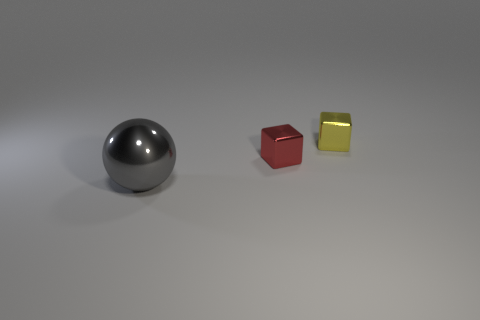There is a shiny cube in front of the small yellow thing; how big is it?
Your answer should be compact. Small. Does the red shiny block have the same size as the gray object in front of the yellow metallic cube?
Keep it short and to the point. No. How many gray shiny balls have the same size as the yellow metallic cube?
Give a very brief answer. 0. The metallic thing that is in front of the yellow block and behind the big metal ball is what color?
Your answer should be very brief. Red. Are there fewer yellow shiny blocks than cubes?
Give a very brief answer. Yes. Are there the same number of small red cubes right of the large gray shiny object and large gray balls that are in front of the yellow metal cube?
Your response must be concise. Yes. How many large gray objects have the same shape as the small red thing?
Offer a terse response. 0. Is there a purple metallic cylinder?
Keep it short and to the point. No. Are the large object and the block that is on the left side of the small yellow thing made of the same material?
Offer a very short reply. Yes. Are there any tiny yellow cylinders that have the same material as the gray sphere?
Offer a very short reply. No. 